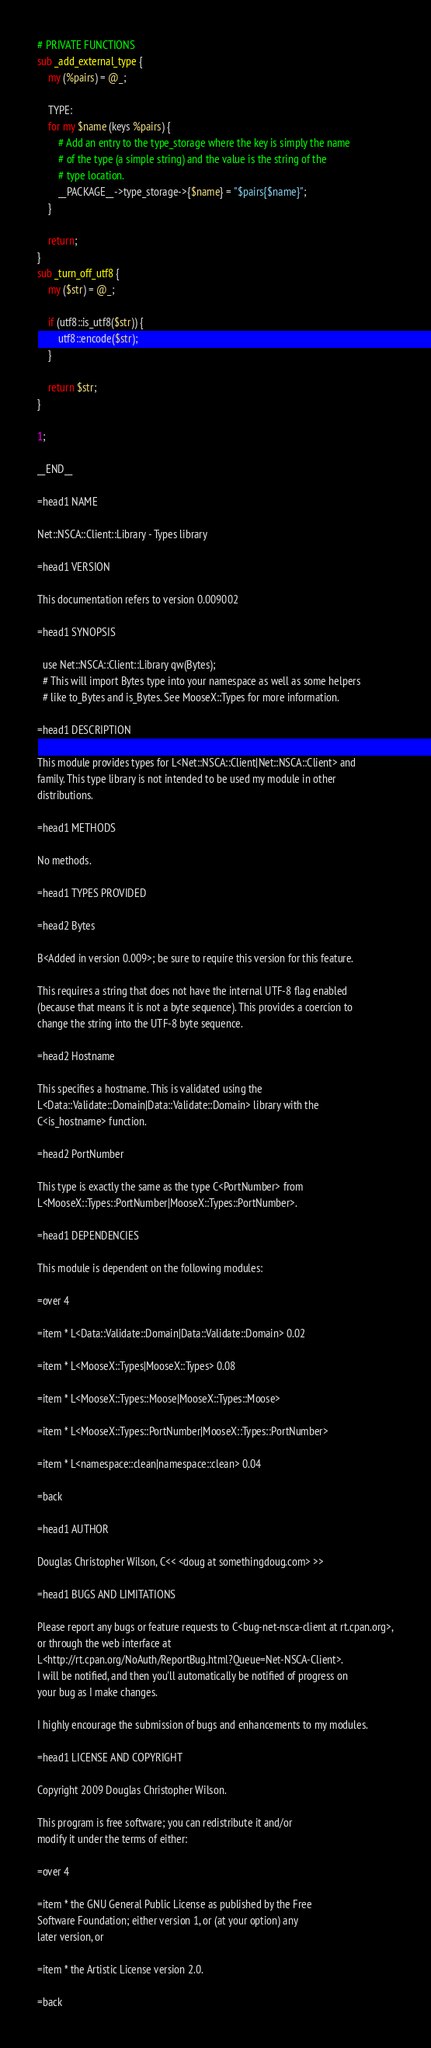Convert code to text. <code><loc_0><loc_0><loc_500><loc_500><_Perl_># PRIVATE FUNCTIONS
sub _add_external_type {
	my (%pairs) = @_;

	TYPE:
	for my $name (keys %pairs) {
		# Add an entry to the type_storage where the key is simply the name
		# of the type (a simple string) and the value is the string of the
		# type location.
		__PACKAGE__->type_storage->{$name} = "$pairs{$name}";
	}

	return;
}
sub _turn_off_utf8 {
	my ($str) = @_;

	if (utf8::is_utf8($str)) {
		utf8::encode($str);
	}

	return $str;
}

1;

__END__

=head1 NAME

Net::NSCA::Client::Library - Types library

=head1 VERSION

This documentation refers to version 0.009002

=head1 SYNOPSIS

  use Net::NSCA::Client::Library qw(Bytes);
  # This will import Bytes type into your namespace as well as some helpers
  # like to_Bytes and is_Bytes. See MooseX::Types for more information.

=head1 DESCRIPTION

This module provides types for L<Net::NSCA::Client|Net::NSCA::Client> and
family. This type library is not intended to be used my module in other
distributions.

=head1 METHODS

No methods.

=head1 TYPES PROVIDED

=head2 Bytes

B<Added in version 0.009>; be sure to require this version for this feature.

This requires a string that does not have the internal UTF-8 flag enabled
(because that means it is not a byte sequence). This provides a coercion to
change the string into the UTF-8 byte sequence.

=head2 Hostname

This specifies a hostname. This is validated using the
L<Data::Validate::Domain|Data::Validate::Domain> library with the
C<is_hostname> function.

=head2 PortNumber

This type is exactly the same as the type C<PortNumber> from
L<MooseX::Types::PortNumber|MooseX::Types::PortNumber>.

=head1 DEPENDENCIES

This module is dependent on the following modules:

=over 4

=item * L<Data::Validate::Domain|Data::Validate::Domain> 0.02

=item * L<MooseX::Types|MooseX::Types> 0.08

=item * L<MooseX::Types::Moose|MooseX::Types::Moose>

=item * L<MooseX::Types::PortNumber|MooseX::Types::PortNumber>

=item * L<namespace::clean|namespace::clean> 0.04

=back

=head1 AUTHOR

Douglas Christopher Wilson, C<< <doug at somethingdoug.com> >>

=head1 BUGS AND LIMITATIONS

Please report any bugs or feature requests to C<bug-net-nsca-client at rt.cpan.org>,
or through the web interface at
L<http://rt.cpan.org/NoAuth/ReportBug.html?Queue=Net-NSCA-Client>.
I will be notified, and then you'll automatically be notified of progress on
your bug as I make changes.

I highly encourage the submission of bugs and enhancements to my modules.

=head1 LICENSE AND COPYRIGHT

Copyright 2009 Douglas Christopher Wilson.

This program is free software; you can redistribute it and/or
modify it under the terms of either:

=over 4

=item * the GNU General Public License as published by the Free
Software Foundation; either version 1, or (at your option) any
later version, or

=item * the Artistic License version 2.0.

=back
</code> 